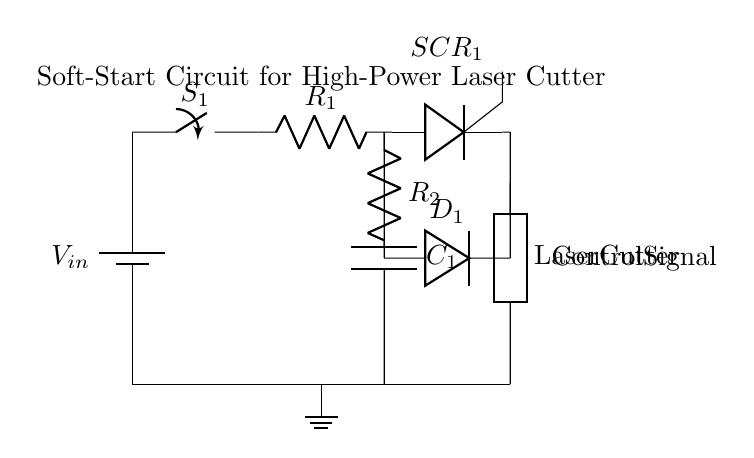What is the function of the component labeled SCR_1? SCR_1 is a thyristor, used to control power delivery to the load by allowing current to flow only when triggered.
Answer: thyristor What does the resistor R_1 do in this circuit? R_1 is part of the soft-start circuit and limits the initial current flow to the capacitor C_1, allowing gradual charging and preventing inrush current.
Answer: current limiting Which component is responsible for protection against reverse polarity? D_1 is a diode, which provides protection by allowing current to flow in only one direction, preventing damaging reverse current.
Answer: diode What type of load is connected to this circuit? The load is a laser cutter, indicated by the label next to the generic component symbol.
Answer: Laser cutter How does the capacitor C_1 affect the startup of the circuit? C_1 stores charge and affects the timing of the circuit by gradually increasing the voltage across it, allowing for a controlled start of the connected load.
Answer: voltage timing What type of circuit is this? This is a soft-start circuit, designed to reduce inrush current and prevent damage to high-power appliances.
Answer: soft-start circuit What is the purpose of the switch S_1? S_1 is the main switch to control the overall power supply to the circuit, allowing the user to turn the circuit on or off.
Answer: power control 